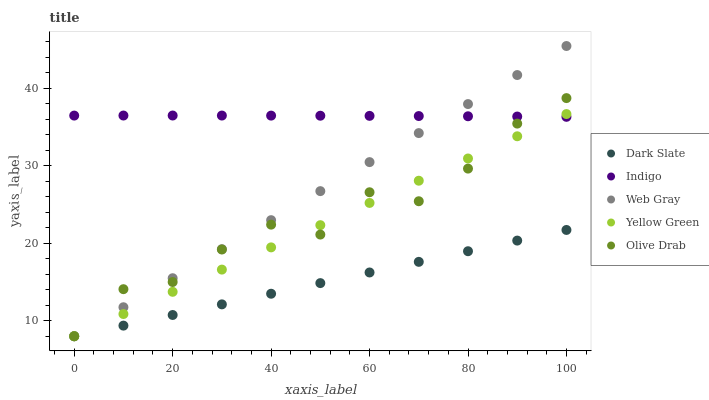Does Dark Slate have the minimum area under the curve?
Answer yes or no. Yes. Does Indigo have the maximum area under the curve?
Answer yes or no. Yes. Does Web Gray have the minimum area under the curve?
Answer yes or no. No. Does Web Gray have the maximum area under the curve?
Answer yes or no. No. Is Dark Slate the smoothest?
Answer yes or no. Yes. Is Olive Drab the roughest?
Answer yes or no. Yes. Is Web Gray the smoothest?
Answer yes or no. No. Is Web Gray the roughest?
Answer yes or no. No. Does Dark Slate have the lowest value?
Answer yes or no. Yes. Does Indigo have the lowest value?
Answer yes or no. No. Does Web Gray have the highest value?
Answer yes or no. Yes. Does Indigo have the highest value?
Answer yes or no. No. Is Dark Slate less than Indigo?
Answer yes or no. Yes. Is Indigo greater than Dark Slate?
Answer yes or no. Yes. Does Indigo intersect Yellow Green?
Answer yes or no. Yes. Is Indigo less than Yellow Green?
Answer yes or no. No. Is Indigo greater than Yellow Green?
Answer yes or no. No. Does Dark Slate intersect Indigo?
Answer yes or no. No. 